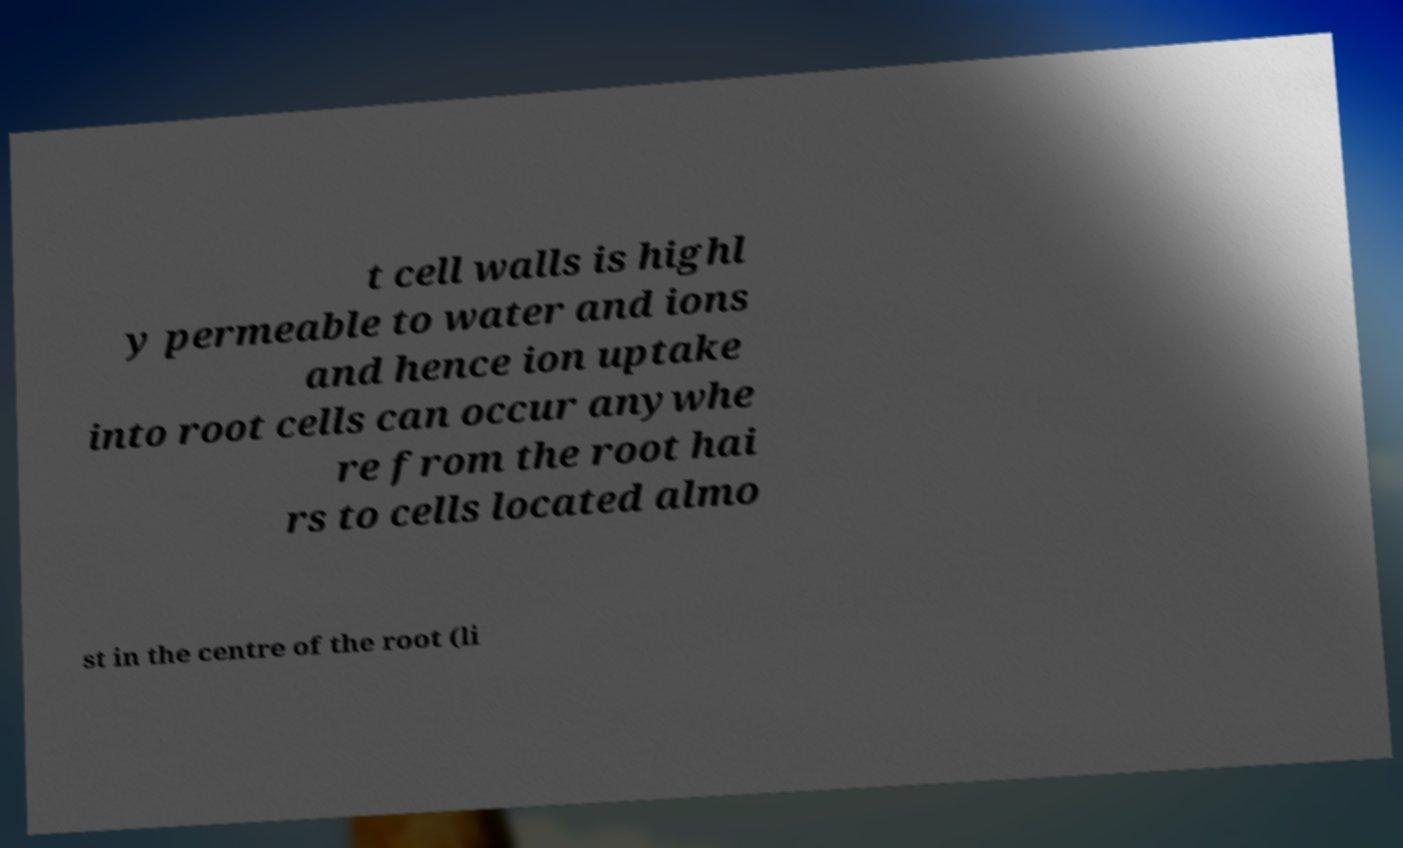Please identify and transcribe the text found in this image. t cell walls is highl y permeable to water and ions and hence ion uptake into root cells can occur anywhe re from the root hai rs to cells located almo st in the centre of the root (li 